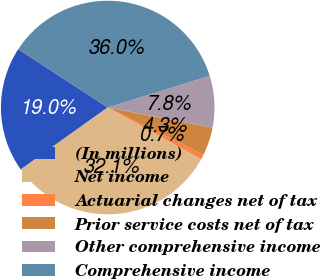<chart> <loc_0><loc_0><loc_500><loc_500><pie_chart><fcel>(In millions)<fcel>Net income<fcel>Actuarial changes net of tax<fcel>Prior service costs net of tax<fcel>Other comprehensive income<fcel>Comprehensive income<nl><fcel>19.05%<fcel>32.12%<fcel>0.74%<fcel>4.27%<fcel>7.8%<fcel>36.02%<nl></chart> 